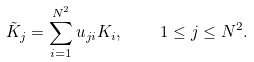<formula> <loc_0><loc_0><loc_500><loc_500>\tilde { K } _ { j } = \sum _ { i = 1 } ^ { N ^ { 2 } } u _ { j i } K _ { i } , \quad 1 \leq j \leq N ^ { 2 } .</formula> 